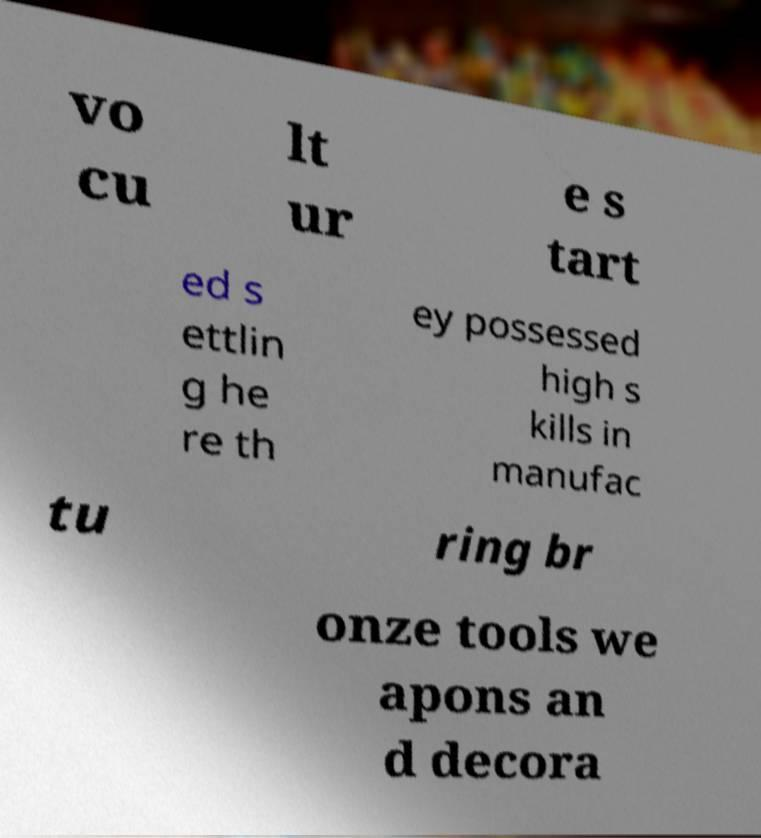What messages or text are displayed in this image? I need them in a readable, typed format. vo cu lt ur e s tart ed s ettlin g he re th ey possessed high s kills in manufac tu ring br onze tools we apons an d decora 